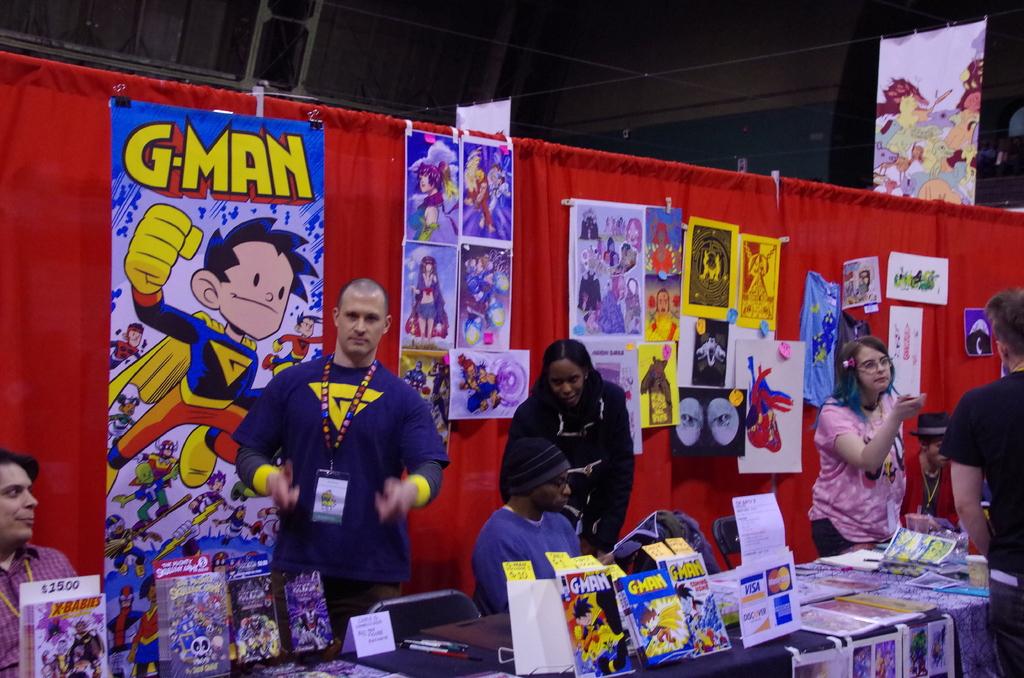Is visa accepted at this booth?
Make the answer very short. Yes. 